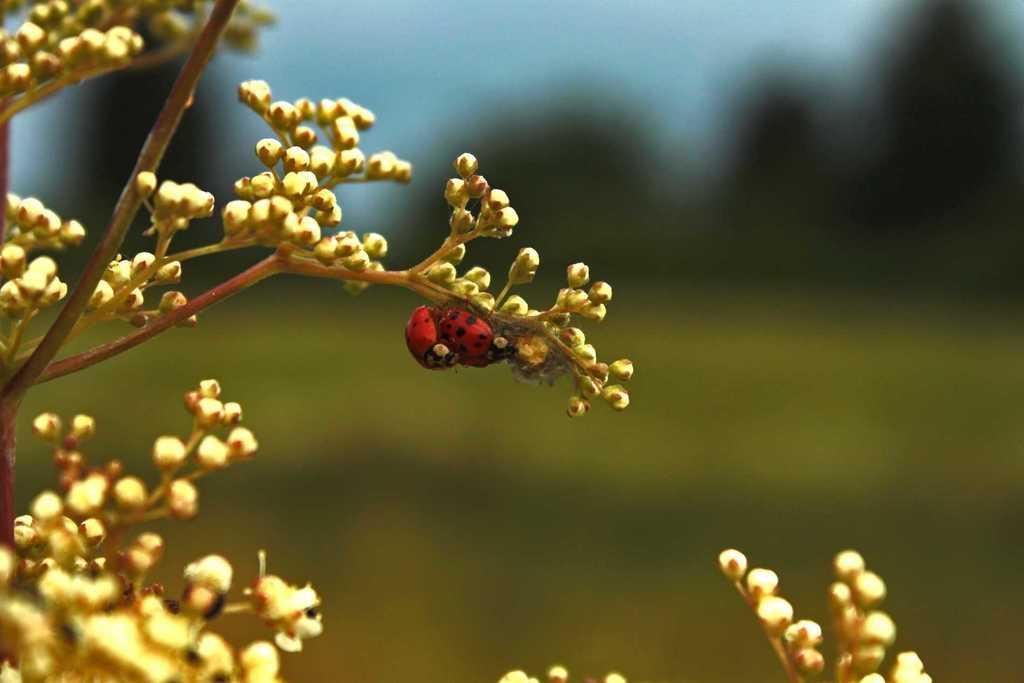Describe this image in one or two sentences. In this image in the front there is a plant and on the plant there is a bee and the background is blurry. 